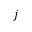<formula> <loc_0><loc_0><loc_500><loc_500>j</formula> 